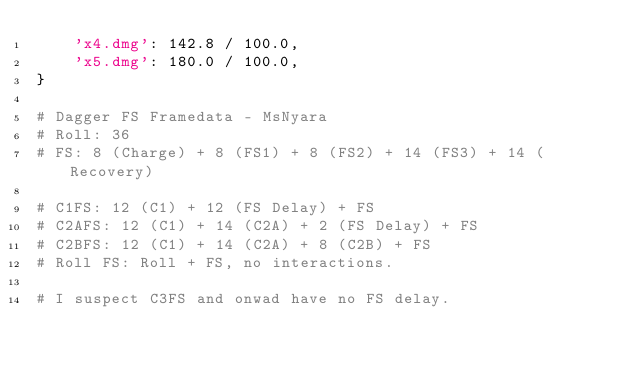<code> <loc_0><loc_0><loc_500><loc_500><_Python_>    'x4.dmg': 142.8 / 100.0,
    'x5.dmg': 180.0 / 100.0,
}

# Dagger FS Framedata - MsNyara
# Roll: 36
# FS: 8 (Charge) + 8 (FS1) + 8 (FS2) + 14 (FS3) + 14 (Recovery)

# C1FS: 12 (C1) + 12 (FS Delay) + FS
# C2AFS: 12 (C1) + 14 (C2A) + 2 (FS Delay) + FS
# C2BFS: 12 (C1) + 14 (C2A) + 8 (C2B) + FS
# Roll FS: Roll + FS, no interactions.

# I suspect C3FS and onwad have no FS delay.</code> 